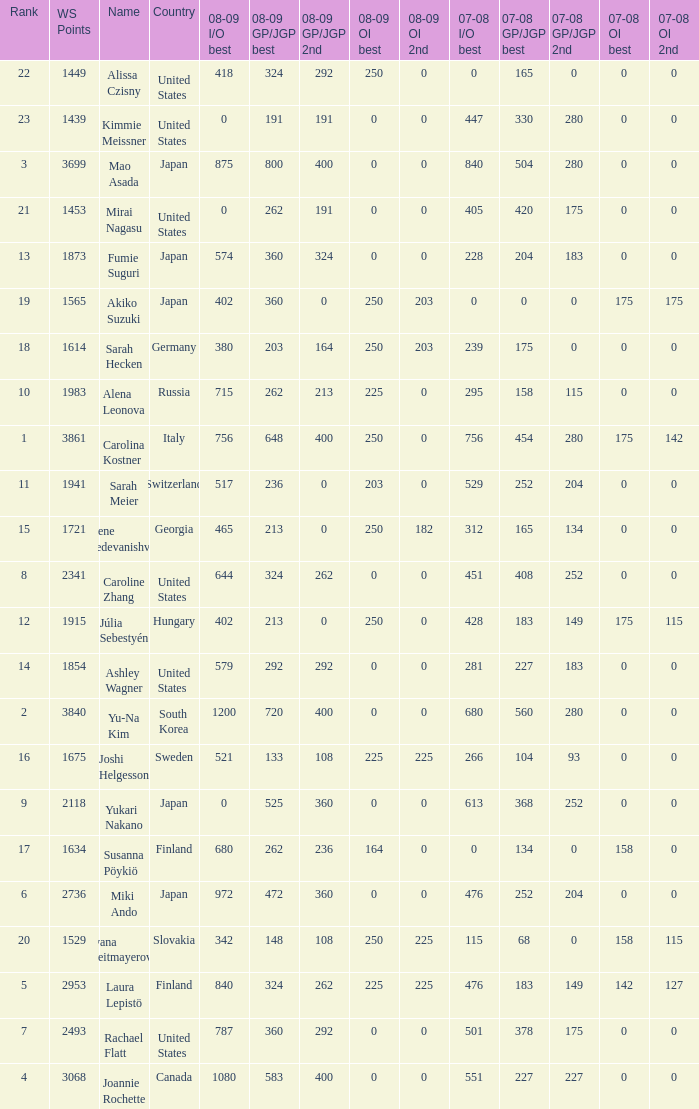Could you help me parse every detail presented in this table? {'header': ['Rank', 'WS Points', 'Name', 'Country', '08-09 I/O best', '08-09 GP/JGP best', '08-09 GP/JGP 2nd', '08-09 OI best', '08-09 OI 2nd', '07-08 I/O best', '07-08 GP/JGP best', '07-08 GP/JGP 2nd', '07-08 OI best', '07-08 OI 2nd'], 'rows': [['22', '1449', 'Alissa Czisny', 'United States', '418', '324', '292', '250', '0', '0', '165', '0', '0', '0'], ['23', '1439', 'Kimmie Meissner', 'United States', '0', '191', '191', '0', '0', '447', '330', '280', '0', '0'], ['3', '3699', 'Mao Asada', 'Japan', '875', '800', '400', '0', '0', '840', '504', '280', '0', '0'], ['21', '1453', 'Mirai Nagasu', 'United States', '0', '262', '191', '0', '0', '405', '420', '175', '0', '0'], ['13', '1873', 'Fumie Suguri', 'Japan', '574', '360', '324', '0', '0', '228', '204', '183', '0', '0'], ['19', '1565', 'Akiko Suzuki', 'Japan', '402', '360', '0', '250', '203', '0', '0', '0', '175', '175'], ['18', '1614', 'Sarah Hecken', 'Germany', '380', '203', '164', '250', '203', '239', '175', '0', '0', '0'], ['10', '1983', 'Alena Leonova', 'Russia', '715', '262', '213', '225', '0', '295', '158', '115', '0', '0'], ['1', '3861', 'Carolina Kostner', 'Italy', '756', '648', '400', '250', '0', '756', '454', '280', '175', '142'], ['11', '1941', 'Sarah Meier', 'Switzerland', '517', '236', '0', '203', '0', '529', '252', '204', '0', '0'], ['15', '1721', 'Elene Gedevanishvili', 'Georgia', '465', '213', '0', '250', '182', '312', '165', '134', '0', '0'], ['8', '2341', 'Caroline Zhang', 'United States', '644', '324', '262', '0', '0', '451', '408', '252', '0', '0'], ['12', '1915', 'Júlia Sebestyén', 'Hungary', '402', '213', '0', '250', '0', '428', '183', '149', '175', '115'], ['14', '1854', 'Ashley Wagner', 'United States', '579', '292', '292', '0', '0', '281', '227', '183', '0', '0'], ['2', '3840', 'Yu-Na Kim', 'South Korea', '1200', '720', '400', '0', '0', '680', '560', '280', '0', '0'], ['16', '1675', 'Joshi Helgesson', 'Sweden', '521', '133', '108', '225', '225', '266', '104', '93', '0', '0'], ['9', '2118', 'Yukari Nakano', 'Japan', '0', '525', '360', '0', '0', '613', '368', '252', '0', '0'], ['17', '1634', 'Susanna Pöykiö', 'Finland', '680', '262', '236', '164', '0', '0', '134', '0', '158', '0'], ['6', '2736', 'Miki Ando', 'Japan', '972', '472', '360', '0', '0', '476', '252', '204', '0', '0'], ['20', '1529', 'Ivana Reitmayerova', 'Slovakia', '342', '148', '108', '250', '225', '115', '68', '0', '158', '115'], ['5', '2953', 'Laura Lepistö', 'Finland', '840', '324', '262', '225', '225', '476', '183', '149', '142', '127'], ['7', '2493', 'Rachael Flatt', 'United States', '787', '360', '292', '0', '0', '501', '378', '175', '0', '0'], ['4', '3068', 'Joannie Rochette', 'Canada', '1080', '583', '400', '0', '0', '551', '227', '227', '0', '0']]} 08-09 gp/jgp 2nd is 213 and ws points will be what topmost? 1983.0. 